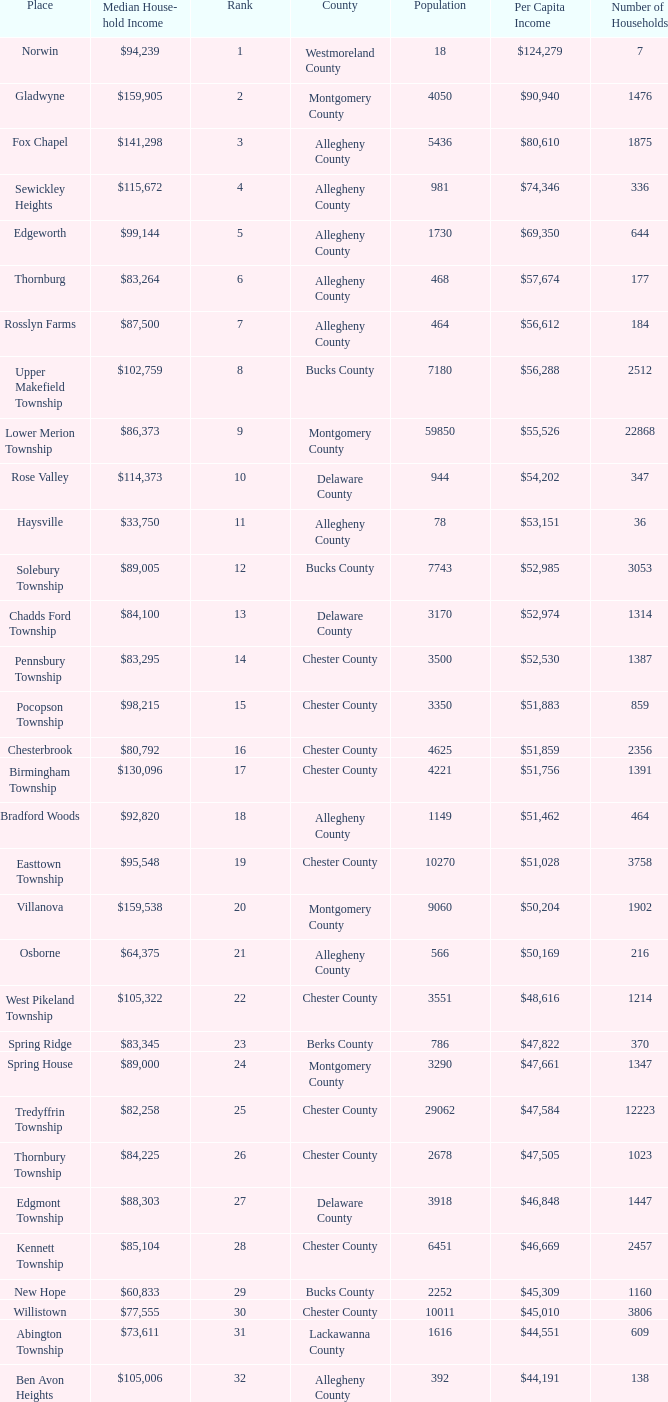What county has 2053 households?  Chester County. 